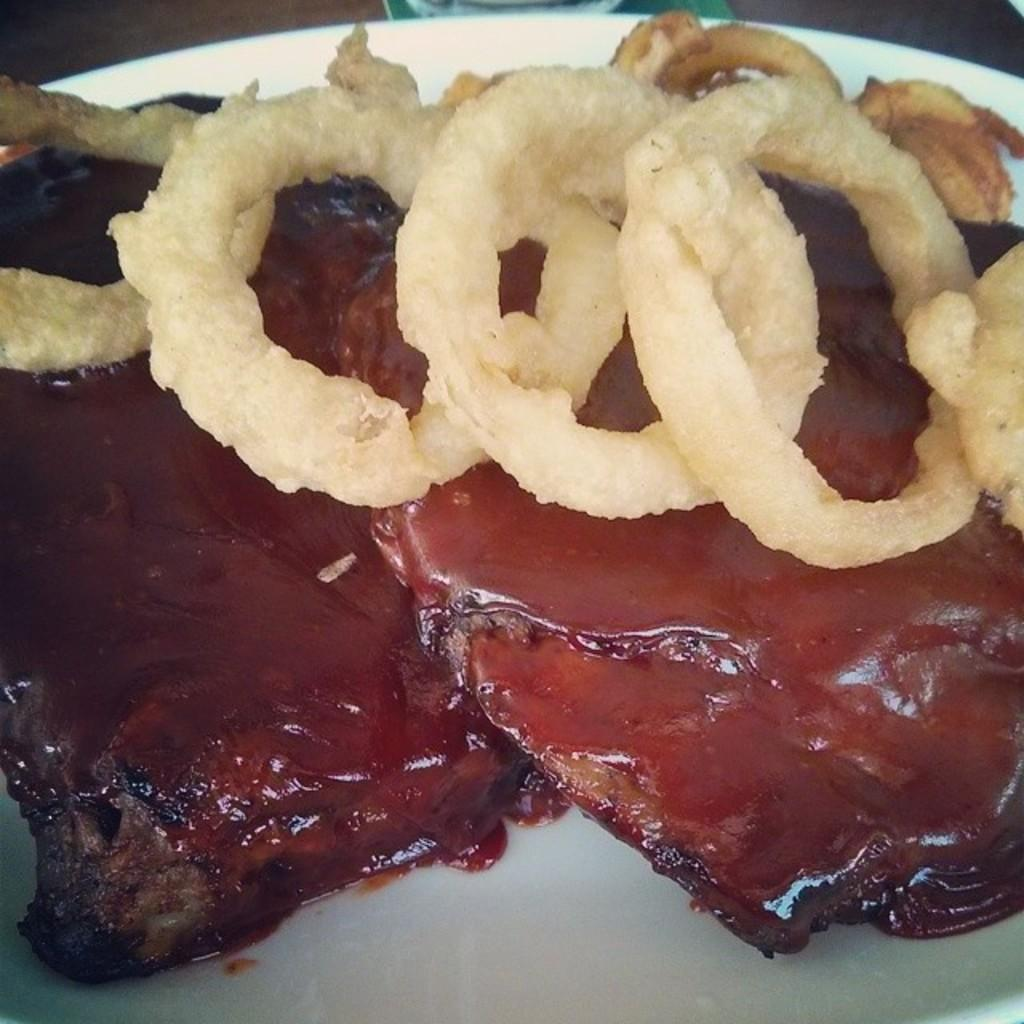What color is the plate in the image? The plate in the image is white colored. What is on the plate? There is a food item on the plate. Can you describe the appearance of the food item? The food item is brown and cream in color. How many threads are visible in the image? There is no mention of threads in the image, so it is not possible to determine the number of threads. 